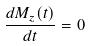Convert formula to latex. <formula><loc_0><loc_0><loc_500><loc_500>\frac { d M _ { z } ( t ) } { d t } = 0</formula> 